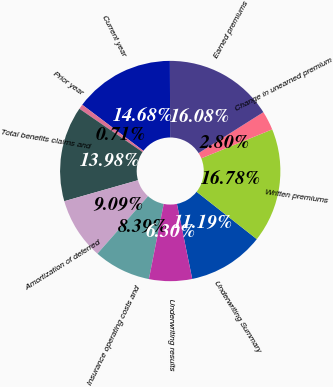Convert chart. <chart><loc_0><loc_0><loc_500><loc_500><pie_chart><fcel>Underwriting Summary<fcel>Written premiums<fcel>Change in unearned premium<fcel>Earned premiums<fcel>Current year<fcel>Prior year<fcel>Total benefits claims and<fcel>Amortization of deferred<fcel>Insurance operating costs and<fcel>Underwriting results<nl><fcel>11.19%<fcel>16.78%<fcel>2.8%<fcel>16.08%<fcel>14.68%<fcel>0.71%<fcel>13.98%<fcel>9.09%<fcel>8.39%<fcel>6.3%<nl></chart> 